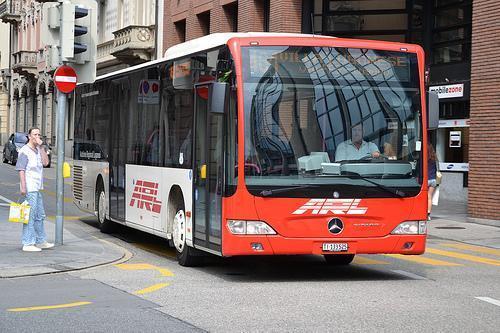How many buses are there?
Give a very brief answer. 1. 